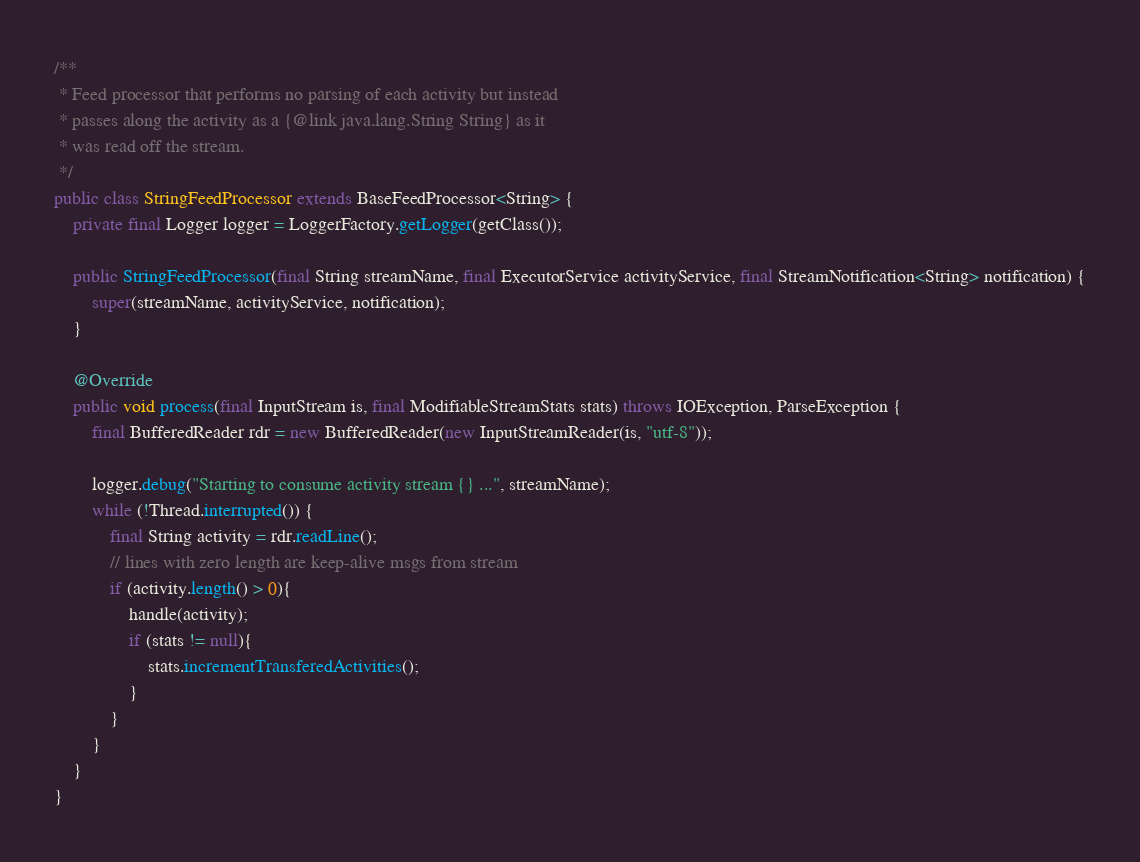Convert code to text. <code><loc_0><loc_0><loc_500><loc_500><_Java_>
/**
 * Feed processor that performs no parsing of each activity but instead
 * passes along the activity as a {@link java.lang.String String} as it 
 * was read off the stream.
 */
public class StringFeedProcessor extends BaseFeedProcessor<String> {
    private final Logger logger = LoggerFactory.getLogger(getClass());

	public StringFeedProcessor(final String streamName, final ExecutorService activityService, final StreamNotification<String> notification) {
		super(streamName, activityService, notification);
	}

	@Override
	public void process(final InputStream is, final ModifiableStreamStats stats) throws IOException, ParseException {
		final BufferedReader rdr = new BufferedReader(new InputStreamReader(is, "utf-8"));
		
        logger.debug("Starting to consume activity stream {} ...", streamName);
        while (!Thread.interrupted()) {
        	final String activity = rdr.readLine();
        	// lines with zero length are keep-alive msgs from stream
        	if (activity.length() > 0){
        		handle(activity);
        		if (stats != null){
        			stats.incrementTransferedActivities();
        		}
        	}
        }
	}
}
</code> 